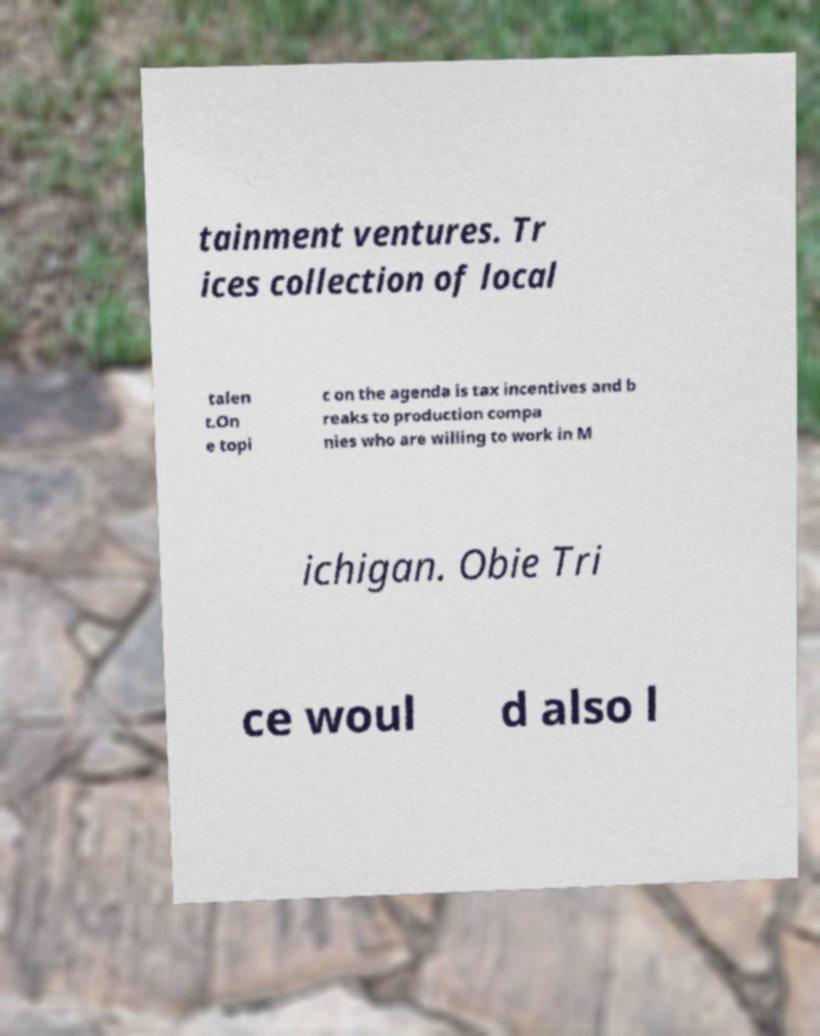Can you accurately transcribe the text from the provided image for me? tainment ventures. Tr ices collection of local talen t.On e topi c on the agenda is tax incentives and b reaks to production compa nies who are willing to work in M ichigan. Obie Tri ce woul d also l 